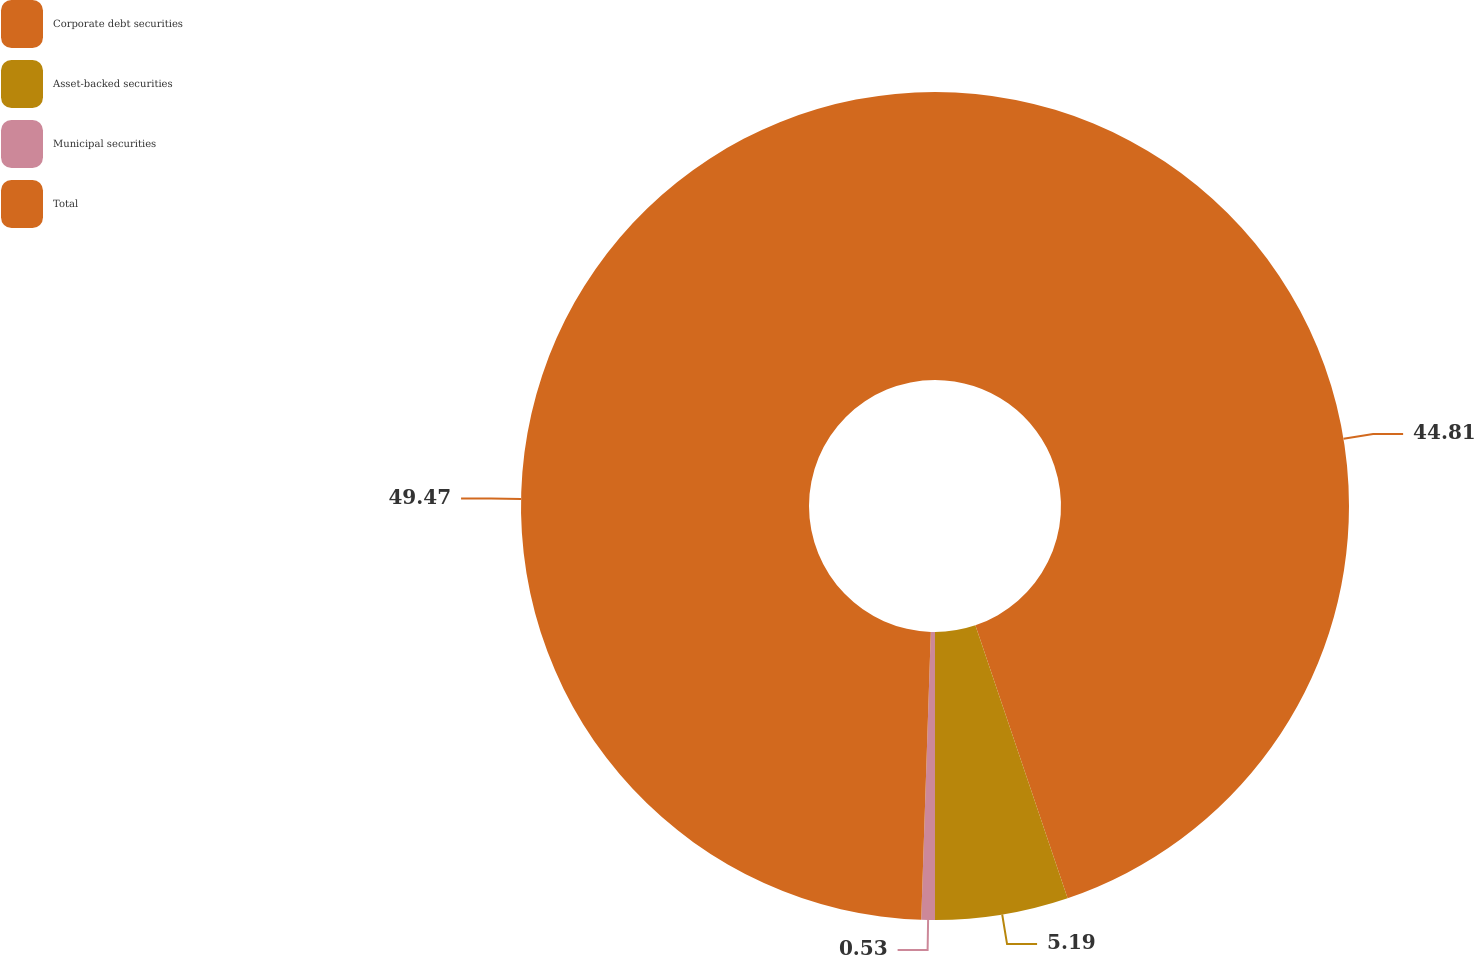Convert chart to OTSL. <chart><loc_0><loc_0><loc_500><loc_500><pie_chart><fcel>Corporate debt securities<fcel>Asset-backed securities<fcel>Municipal securities<fcel>Total<nl><fcel>44.81%<fcel>5.19%<fcel>0.53%<fcel>49.47%<nl></chart> 